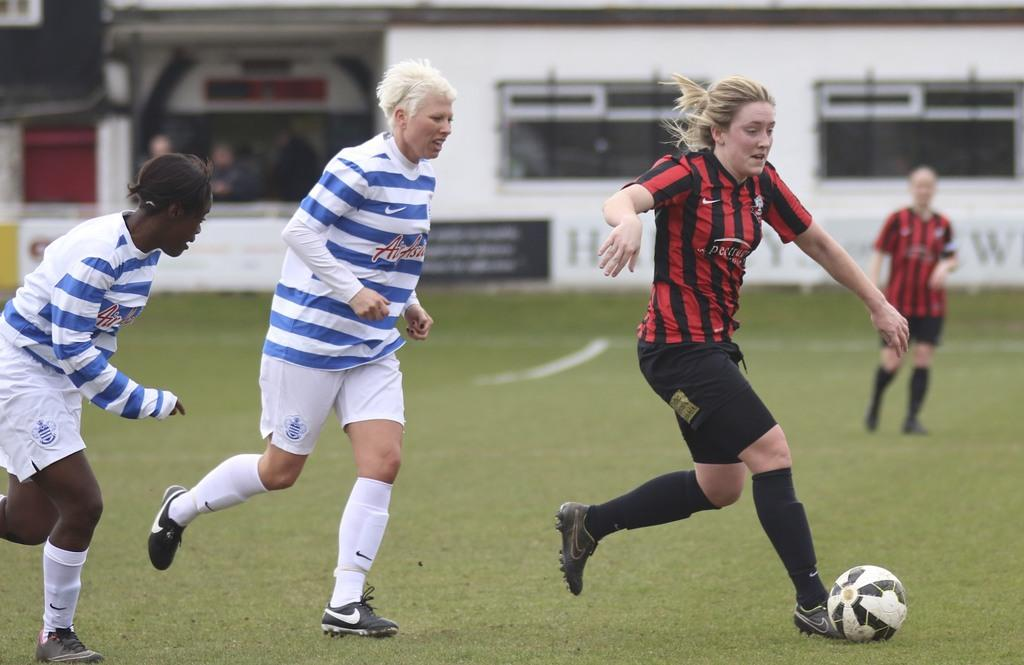What are the players in the image doing? The players in the image are playing on the ground. What object is being used by the players in the game? There is a ball in the image. What can be seen in the background of the image? There is a building in the background. Are there any people visible in the background? Yes, there are two people standing in the background. What type of theory is being discussed by the players during the game? There is no indication in the image that the players are discussing any theory during the game. 